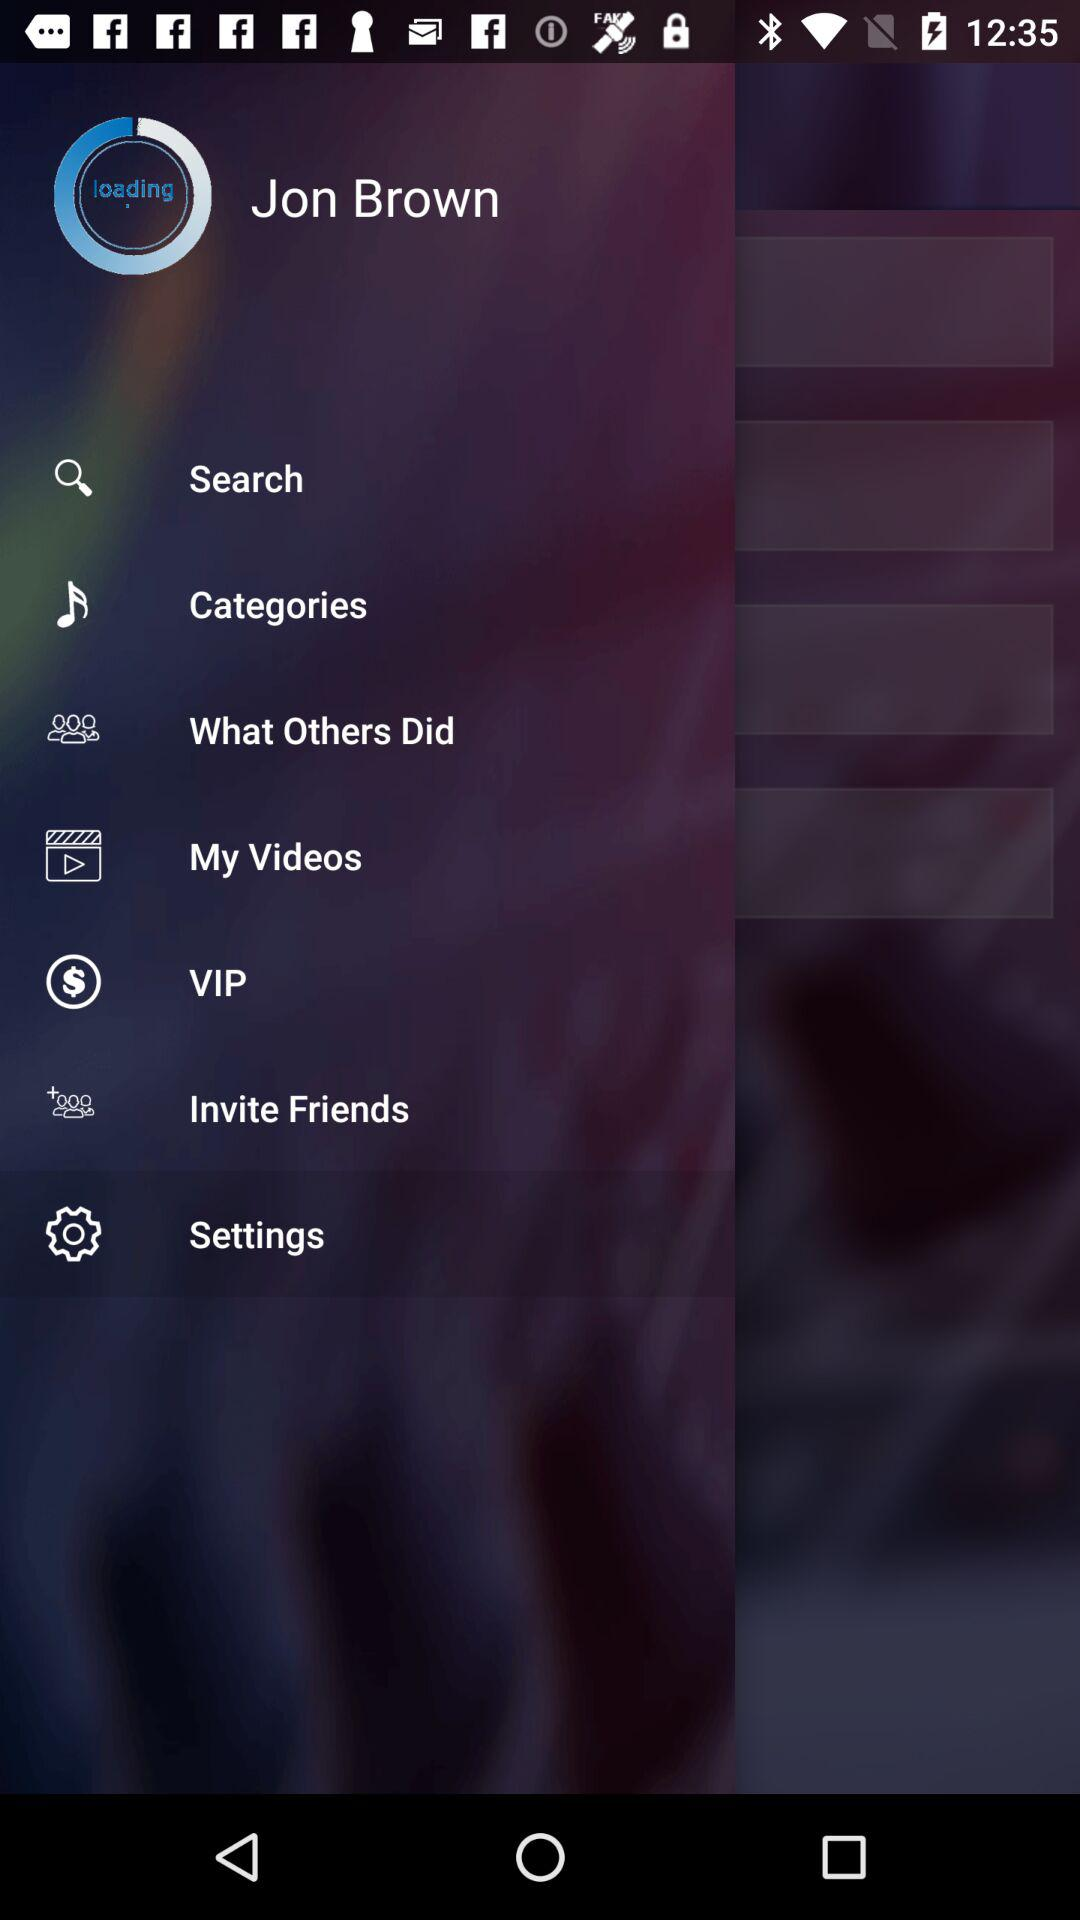Which tab is selected? The selected tab is settings. 